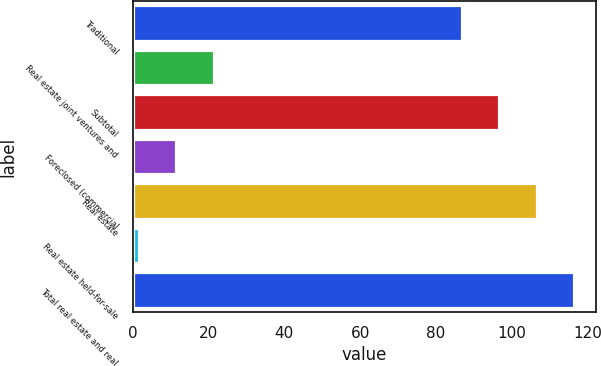Convert chart. <chart><loc_0><loc_0><loc_500><loc_500><bar_chart><fcel>Traditional<fcel>Real estate joint ventures and<fcel>Subtotal<fcel>Foreclosed (commercial<fcel>Real estate<fcel>Real estate held-for-sale<fcel>Total real estate and real<nl><fcel>86.9<fcel>21.36<fcel>96.73<fcel>11.53<fcel>106.56<fcel>1.7<fcel>116.39<nl></chart> 